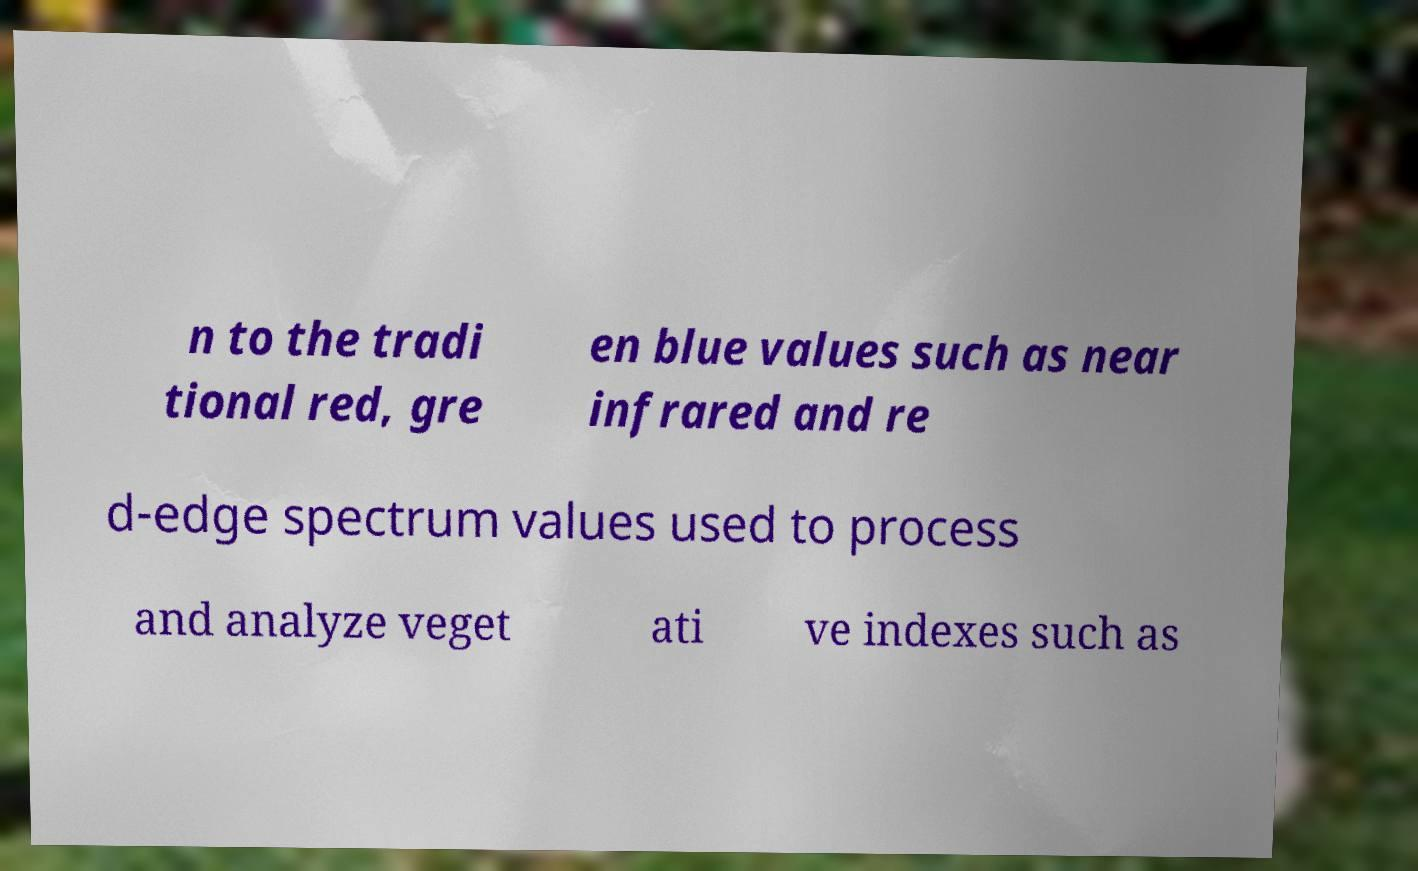Please identify and transcribe the text found in this image. n to the tradi tional red, gre en blue values such as near infrared and re d-edge spectrum values used to process and analyze veget ati ve indexes such as 